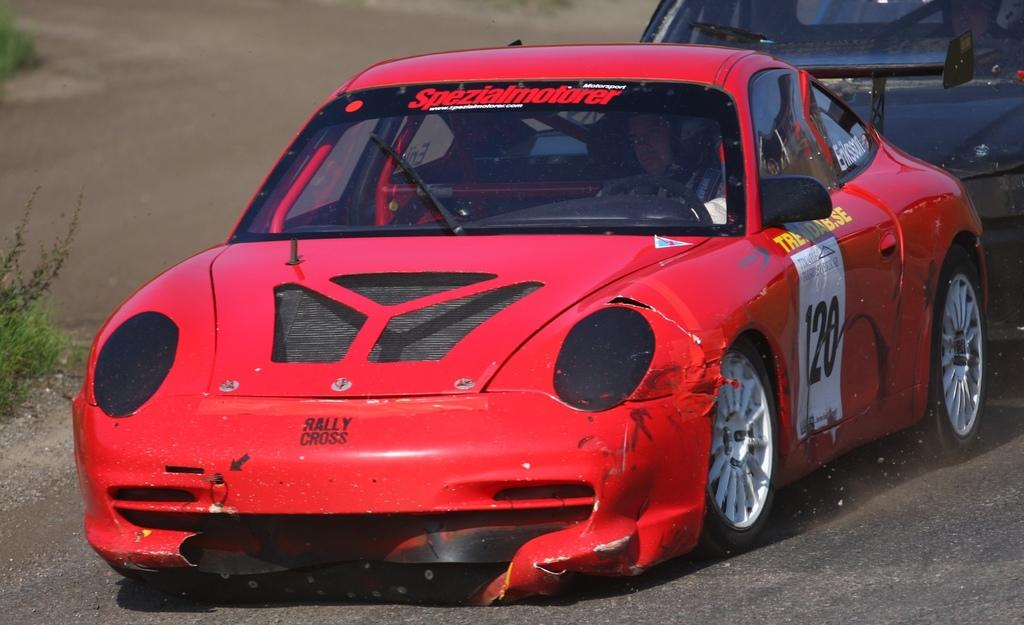How many cars are present in the image? There are two cars in the image. What are the colors of the cars? One car is red in color, and the other car is black in color. What can be seen in the background of the image? There are plants in the background of the image. Is there a clear path visible in the image? Yes, there is a path visible in the image. Where is the bomb hidden in the image? There is no bomb present in the image. What type of cabbage can be seen growing in the background? There are no cabbages visible in the image; only plants are present in the background. 